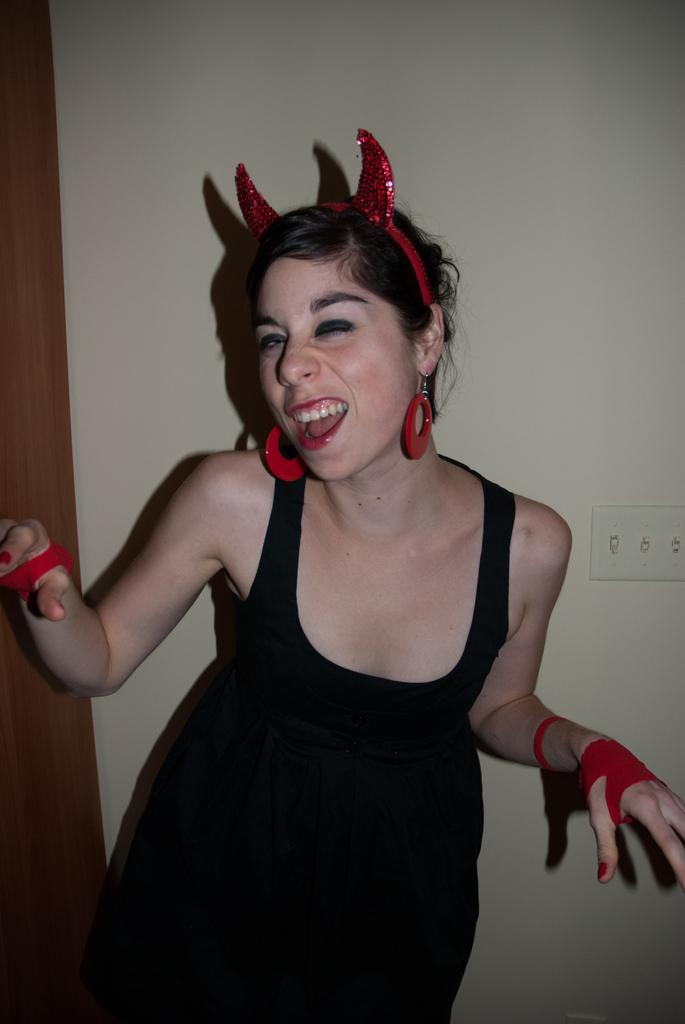Who is the main subject in the image? There is a woman in the center of the image. What color are the woman's clothes? The woman is wearing black clothes. What accessories is the woman wearing? The woman is wearing a red hair band, red earrings, and red gloves. What can be seen in the background of the image? There is a wall in the background of the image. What position does the fan hold in the image? There is no fan present in the image. What does the woman wish for in the image? The image does not provide any information about the woman's wishes or thoughts. 